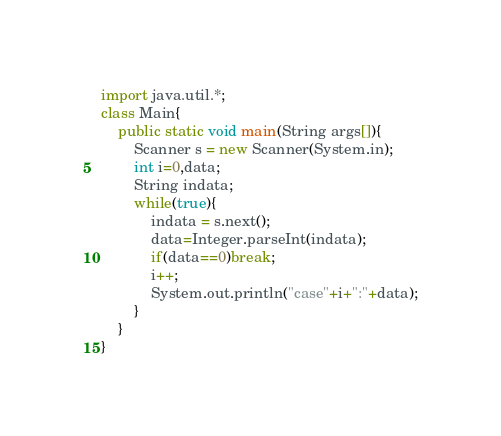Convert code to text. <code><loc_0><loc_0><loc_500><loc_500><_Java_>import java.util.*;
class Main{
	public static void main(String args[]){
		Scanner s = new Scanner(System.in);
		int i=0,data;
		String indata;
		while(true){
			indata = s.next();
			data=Integer.parseInt(indata);
			if(data==0)break;
			i++;
			System.out.println("case"+i+":"+data);
		}
	}
}</code> 